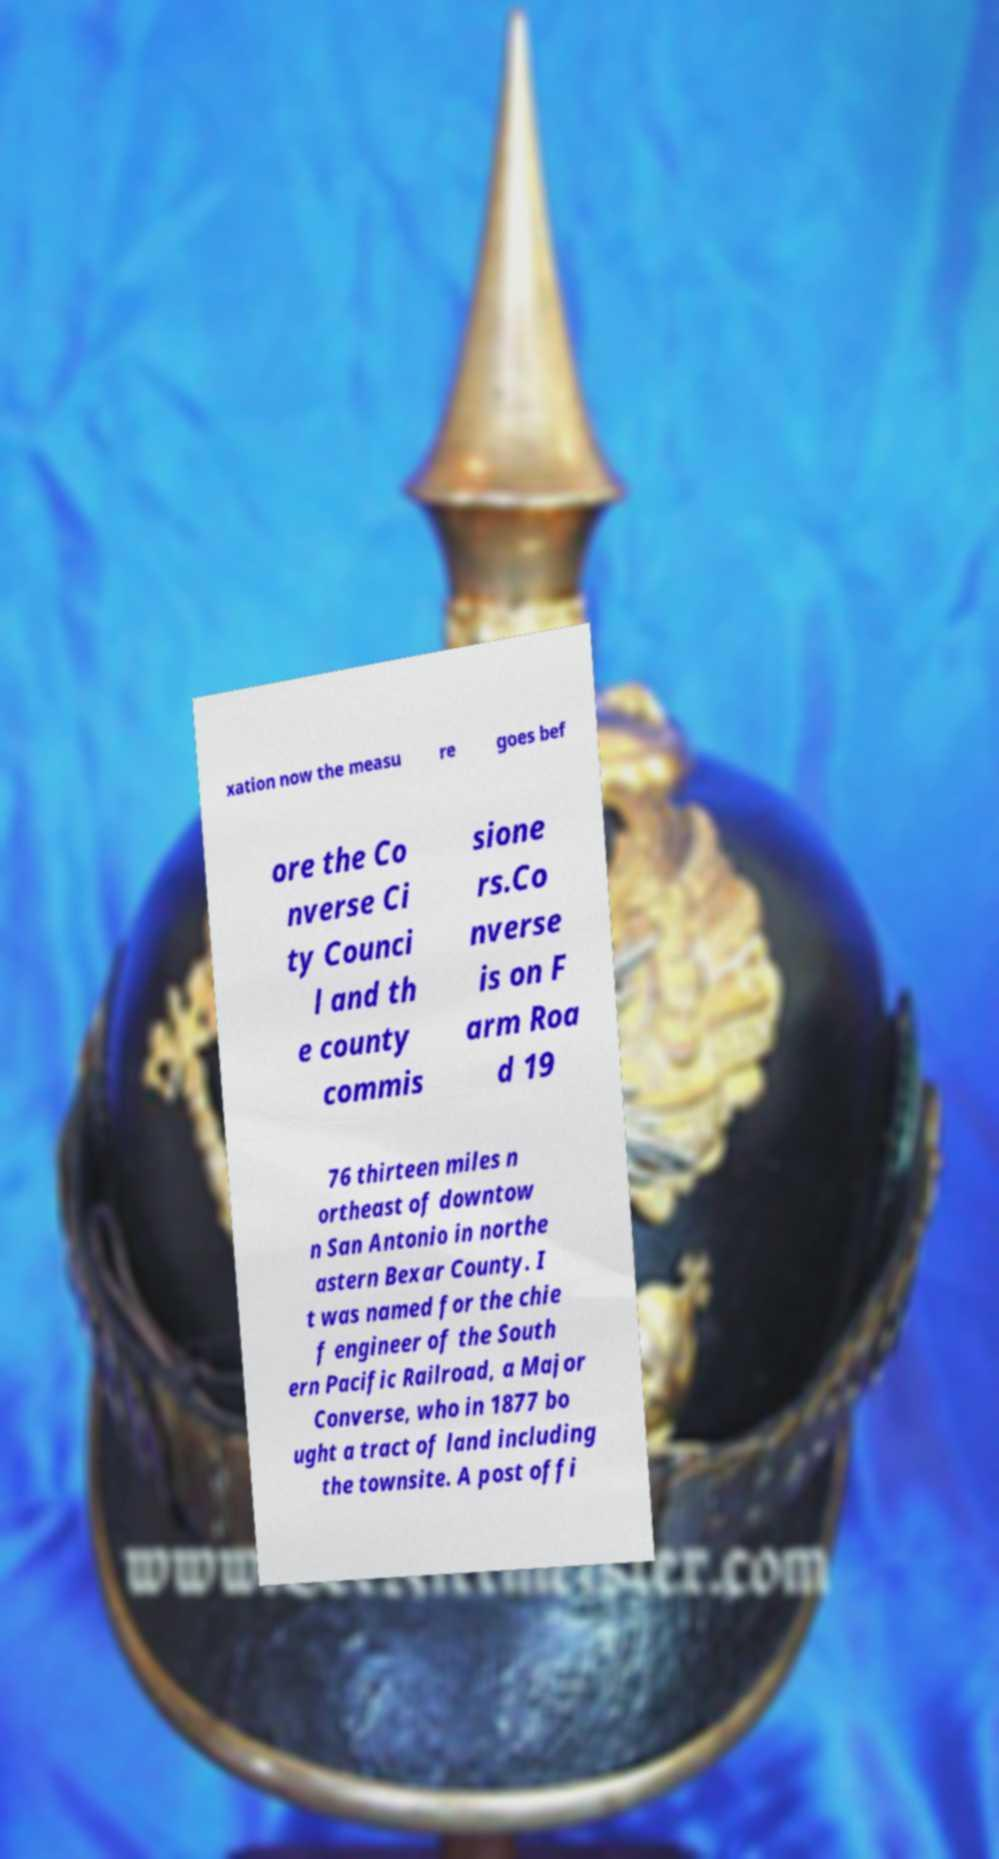Could you extract and type out the text from this image? xation now the measu re goes bef ore the Co nverse Ci ty Counci l and th e county commis sione rs.Co nverse is on F arm Roa d 19 76 thirteen miles n ortheast of downtow n San Antonio in northe astern Bexar County. I t was named for the chie f engineer of the South ern Pacific Railroad, a Major Converse, who in 1877 bo ught a tract of land including the townsite. A post offi 